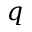Convert formula to latex. <formula><loc_0><loc_0><loc_500><loc_500>q</formula> 